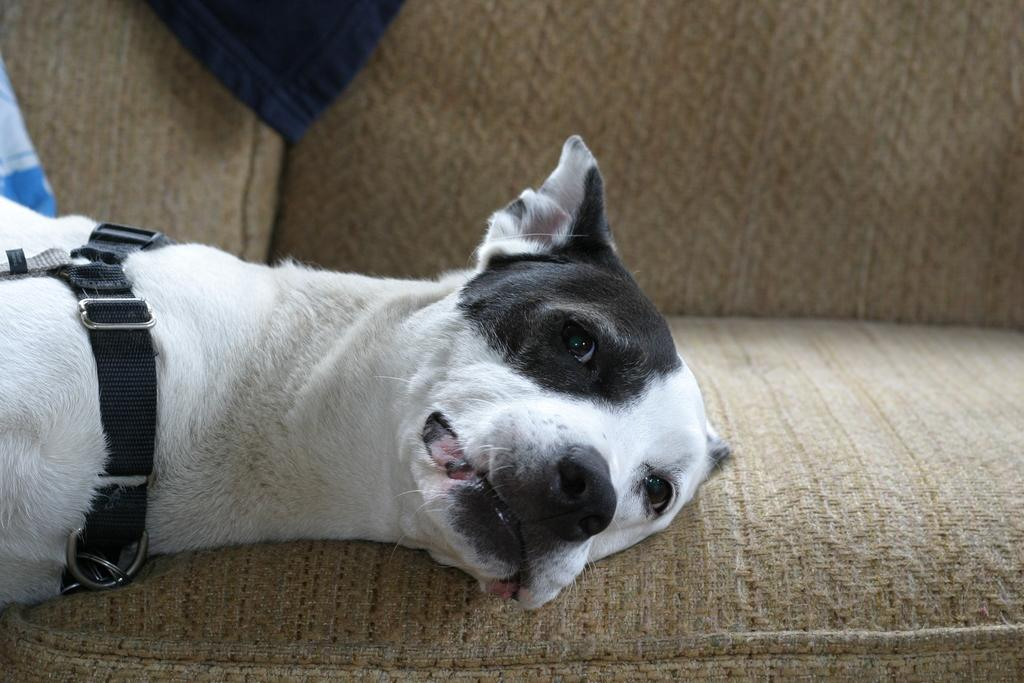What type of animal can be seen in the image? There is a dog in the image. What is the dog doing in the image? The dog is laying down. What can be seen in the background of the image? There is a sofa in the background of the image. What is attached to the dog's neck? The dog has a strap on its neck. What type of material is visible in the image? There is a cloth visible in the image. Can you hear the bell ringing in the garden in the image? There is no bell or garden present in the image; it features a dog laying down with a strap on its neck, a sofa in the background, and a visible cloth. 